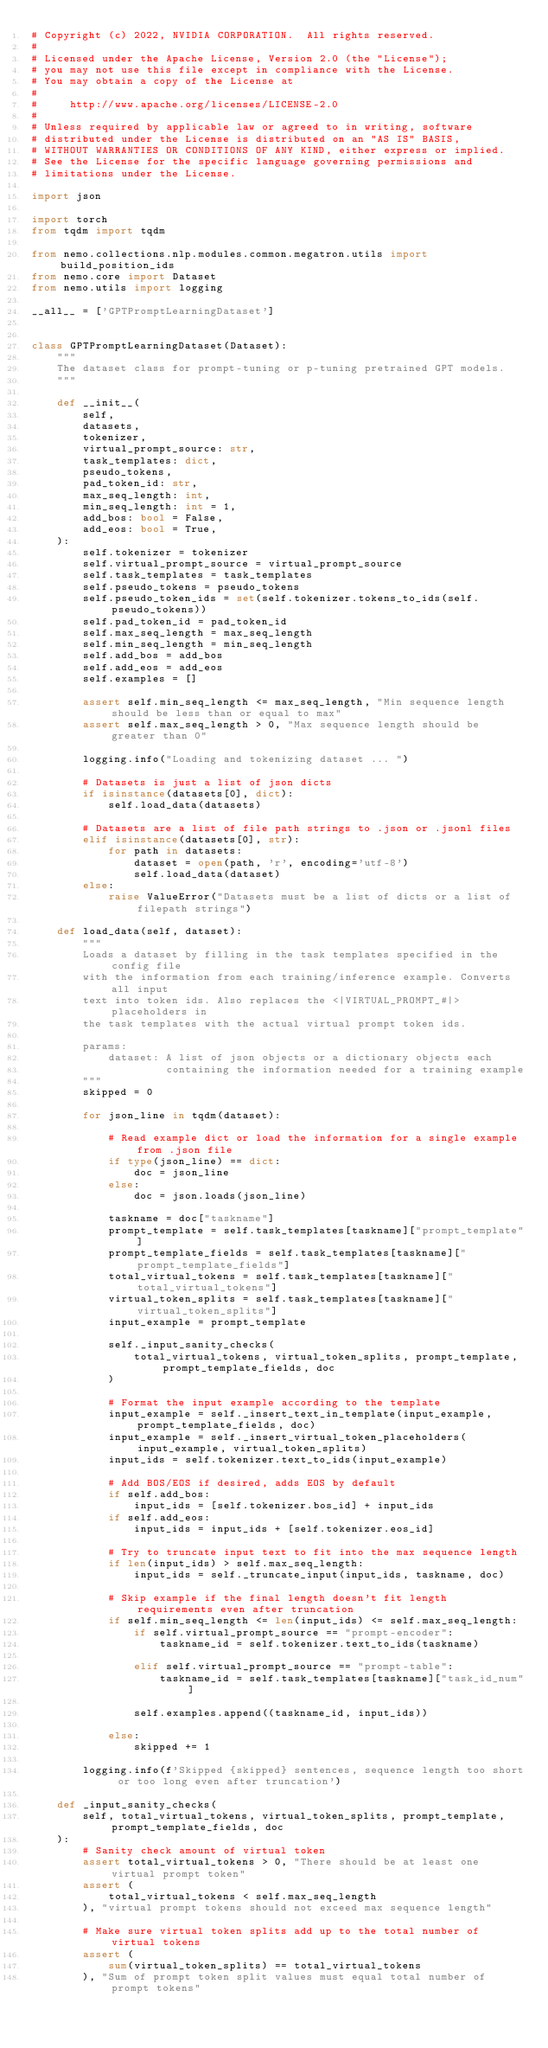Convert code to text. <code><loc_0><loc_0><loc_500><loc_500><_Python_># Copyright (c) 2022, NVIDIA CORPORATION.  All rights reserved.
#
# Licensed under the Apache License, Version 2.0 (the "License");
# you may not use this file except in compliance with the License.
# You may obtain a copy of the License at
#
#     http://www.apache.org/licenses/LICENSE-2.0
#
# Unless required by applicable law or agreed to in writing, software
# distributed under the License is distributed on an "AS IS" BASIS,
# WITHOUT WARRANTIES OR CONDITIONS OF ANY KIND, either express or implied.
# See the License for the specific language governing permissions and
# limitations under the License.

import json

import torch
from tqdm import tqdm

from nemo.collections.nlp.modules.common.megatron.utils import build_position_ids
from nemo.core import Dataset
from nemo.utils import logging

__all__ = ['GPTPromptLearningDataset']


class GPTPromptLearningDataset(Dataset):
    """
    The dataset class for prompt-tuning or p-tuning pretrained GPT models.
    """

    def __init__(
        self,
        datasets,
        tokenizer,
        virtual_prompt_source: str,
        task_templates: dict,
        pseudo_tokens,
        pad_token_id: str,
        max_seq_length: int,
        min_seq_length: int = 1,
        add_bos: bool = False,
        add_eos: bool = True,
    ):
        self.tokenizer = tokenizer
        self.virtual_prompt_source = virtual_prompt_source
        self.task_templates = task_templates
        self.pseudo_tokens = pseudo_tokens
        self.pseudo_token_ids = set(self.tokenizer.tokens_to_ids(self.pseudo_tokens))
        self.pad_token_id = pad_token_id
        self.max_seq_length = max_seq_length
        self.min_seq_length = min_seq_length
        self.add_bos = add_bos
        self.add_eos = add_eos
        self.examples = []

        assert self.min_seq_length <= max_seq_length, "Min sequence length should be less than or equal to max"
        assert self.max_seq_length > 0, "Max sequence length should be greater than 0"

        logging.info("Loading and tokenizing dataset ... ")

        # Datasets is just a list of json dicts
        if isinstance(datasets[0], dict):
            self.load_data(datasets)

        # Datasets are a list of file path strings to .json or .jsonl files
        elif isinstance(datasets[0], str):
            for path in datasets:
                dataset = open(path, 'r', encoding='utf-8')
                self.load_data(dataset)
        else:
            raise ValueError("Datasets must be a list of dicts or a list of filepath strings")

    def load_data(self, dataset):
        """
        Loads a dataset by filling in the task templates specified in the config file
        with the information from each training/inference example. Converts all input 
        text into token ids. Also replaces the <|VIRTUAL_PROMPT_#|> placeholders in 
        the task templates with the actual virtual prompt token ids. 

        params:
            dataset: A list of json objects or a dictionary objects each
                     containing the information needed for a training example
        """
        skipped = 0

        for json_line in tqdm(dataset):

            # Read example dict or load the information for a single example from .json file
            if type(json_line) == dict:
                doc = json_line
            else:
                doc = json.loads(json_line)

            taskname = doc["taskname"]
            prompt_template = self.task_templates[taskname]["prompt_template"]
            prompt_template_fields = self.task_templates[taskname]["prompt_template_fields"]
            total_virtual_tokens = self.task_templates[taskname]["total_virtual_tokens"]
            virtual_token_splits = self.task_templates[taskname]["virtual_token_splits"]
            input_example = prompt_template

            self._input_sanity_checks(
                total_virtual_tokens, virtual_token_splits, prompt_template, prompt_template_fields, doc
            )

            # Format the input example according to the template
            input_example = self._insert_text_in_template(input_example, prompt_template_fields, doc)
            input_example = self._insert_virtual_token_placeholders(input_example, virtual_token_splits)
            input_ids = self.tokenizer.text_to_ids(input_example)

            # Add BOS/EOS if desired, adds EOS by default
            if self.add_bos:
                input_ids = [self.tokenizer.bos_id] + input_ids
            if self.add_eos:
                input_ids = input_ids + [self.tokenizer.eos_id]

            # Try to truncate input text to fit into the max sequence length
            if len(input_ids) > self.max_seq_length:
                input_ids = self._truncate_input(input_ids, taskname, doc)

            # Skip example if the final length doesn't fit length requirements even after truncation
            if self.min_seq_length <= len(input_ids) <= self.max_seq_length:
                if self.virtual_prompt_source == "prompt-encoder":
                    taskname_id = self.tokenizer.text_to_ids(taskname)

                elif self.virtual_prompt_source == "prompt-table":
                    taskname_id = self.task_templates[taskname]["task_id_num"]

                self.examples.append((taskname_id, input_ids))

            else:
                skipped += 1

        logging.info(f'Skipped {skipped} sentences, sequence length too short or too long even after truncation')

    def _input_sanity_checks(
        self, total_virtual_tokens, virtual_token_splits, prompt_template, prompt_template_fields, doc
    ):
        # Sanity check amount of virtual token
        assert total_virtual_tokens > 0, "There should be at least one virtual prompt token"
        assert (
            total_virtual_tokens < self.max_seq_length
        ), "virtual prompt tokens should not exceed max sequence length"

        # Make sure virtual token splits add up to the total number of virtual tokens
        assert (
            sum(virtual_token_splits) == total_virtual_tokens
        ), "Sum of prompt token split values must equal total number of prompt tokens"
</code> 